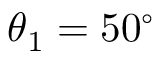Convert formula to latex. <formula><loc_0><loc_0><loc_500><loc_500>\theta _ { 1 } = 5 0 ^ { \circ }</formula> 